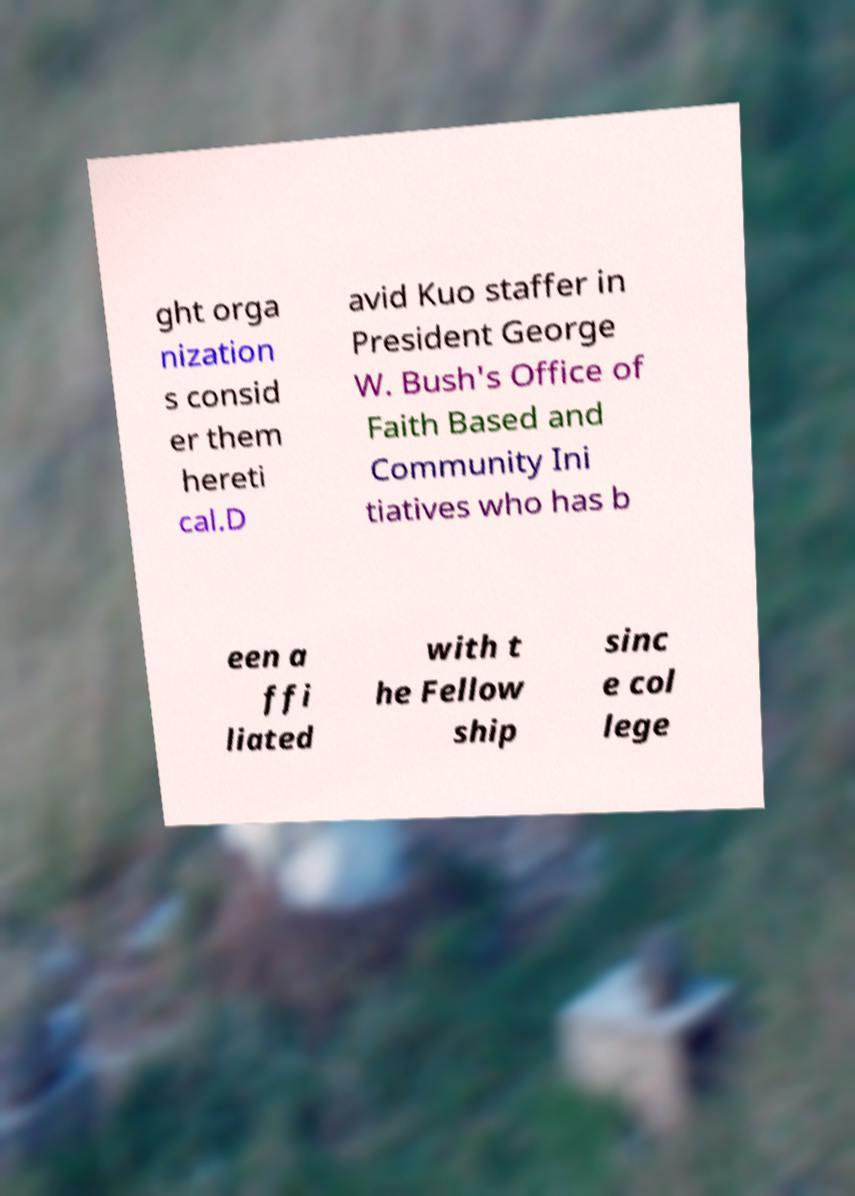For documentation purposes, I need the text within this image transcribed. Could you provide that? ght orga nization s consid er them hereti cal.D avid Kuo staffer in President George W. Bush's Office of Faith Based and Community Ini tiatives who has b een a ffi liated with t he Fellow ship sinc e col lege 